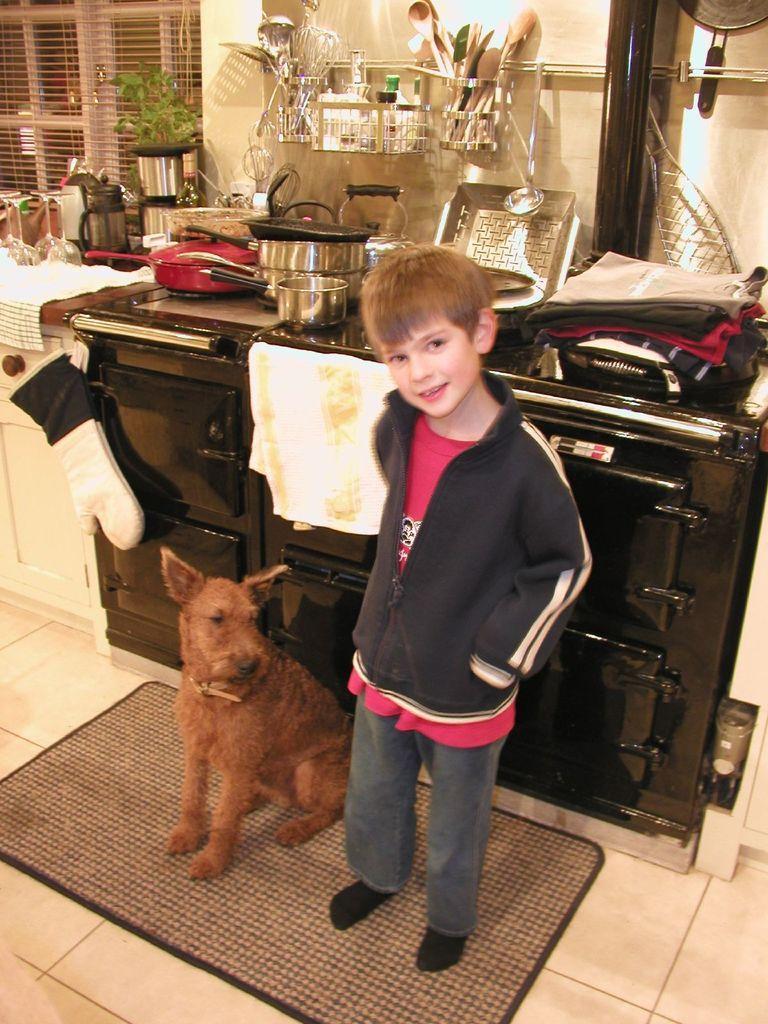How would you summarize this image in a sentence or two? In the picture I can see a dog and a kid wearing jacket standing on mat and in the background there are some utensils, somethings on the surface and there is a wall. 